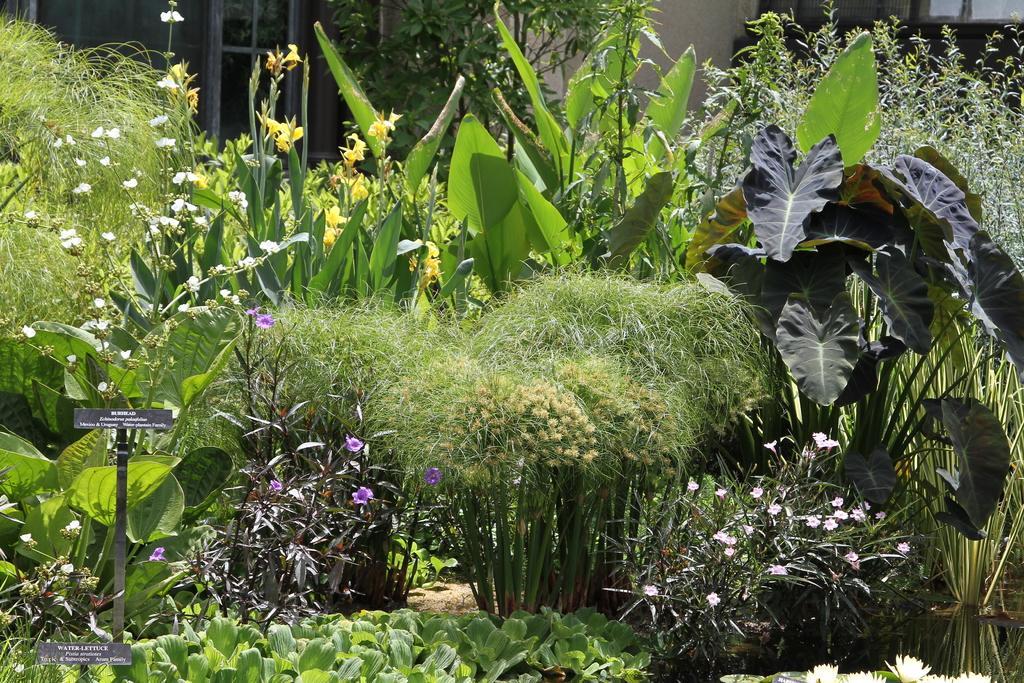Could you give a brief overview of what you see in this image? In this image we can see trees and plants. In the background we can see building. 